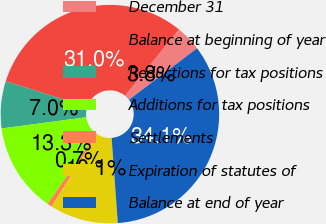Convert chart to OTSL. <chart><loc_0><loc_0><loc_500><loc_500><pie_chart><fcel>December 31<fcel>Balance at beginning of year<fcel>Reductions for tax positions<fcel>Additions for tax positions<fcel>Settlements<fcel>Expiration of statutes of<fcel>Balance at end of year<nl><fcel>3.82%<fcel>31.01%<fcel>6.97%<fcel>13.26%<fcel>0.68%<fcel>10.12%<fcel>34.15%<nl></chart> 